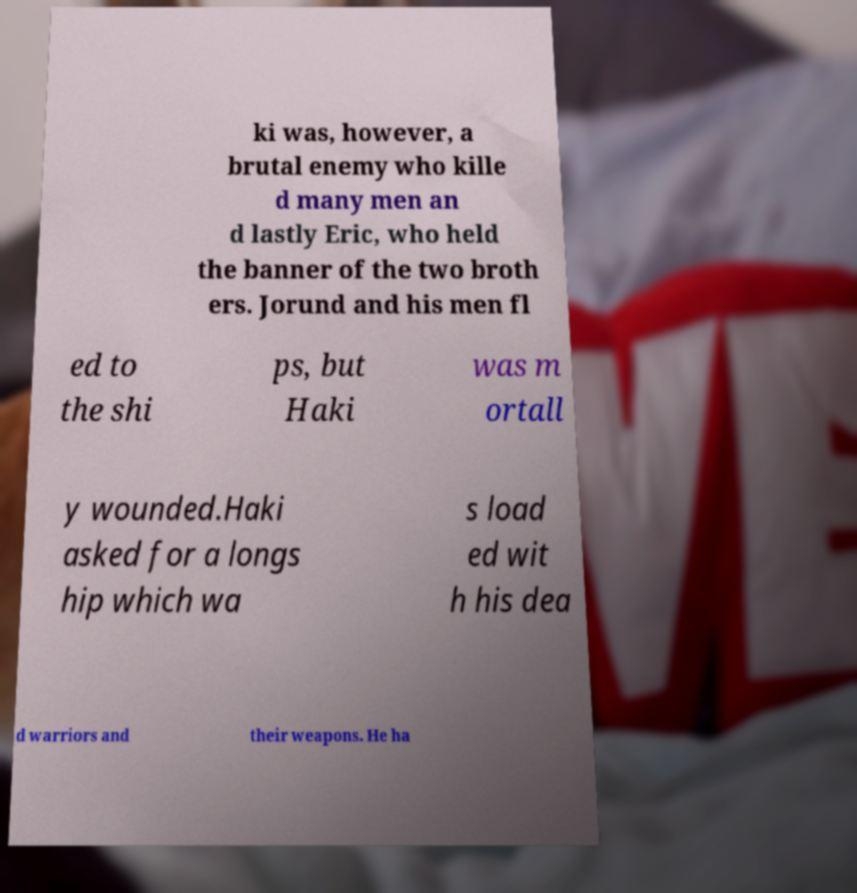Please identify and transcribe the text found in this image. ki was, however, a brutal enemy who kille d many men an d lastly Eric, who held the banner of the two broth ers. Jorund and his men fl ed to the shi ps, but Haki was m ortall y wounded.Haki asked for a longs hip which wa s load ed wit h his dea d warriors and their weapons. He ha 